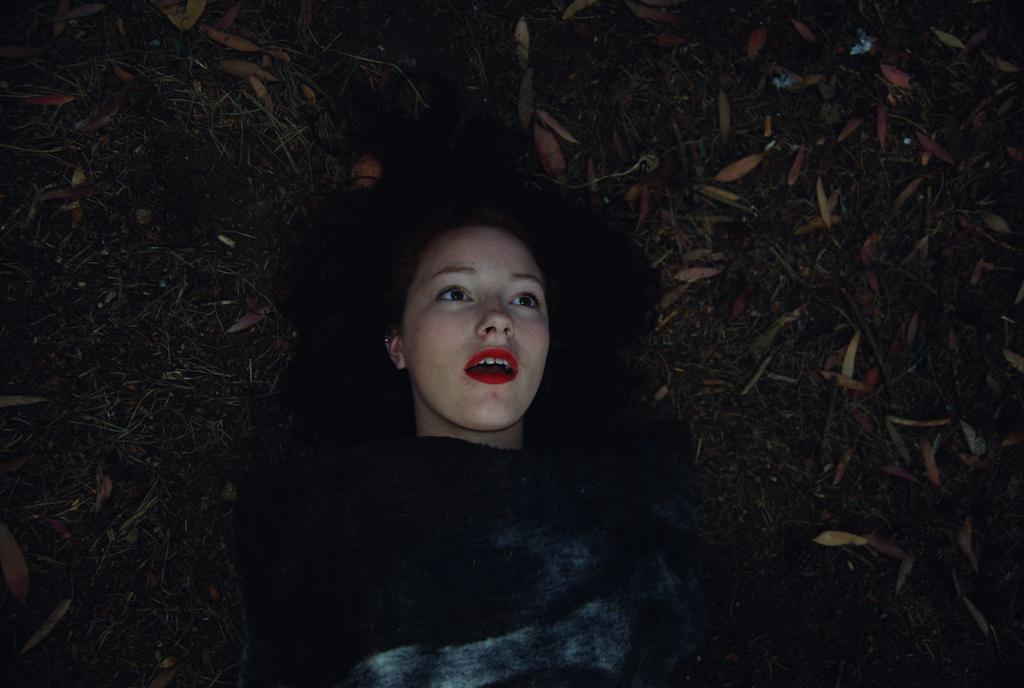Who is present in the image? There is a woman in the image. What is the woman doing in the image? The woman is lying on the ground. What is covering the ground in the image? The ground is covered with dry leaves. What songs are being sung by the group in the image? There is no group or singing present in the image; it features a woman lying on the ground with dry leaves covering the ground. 